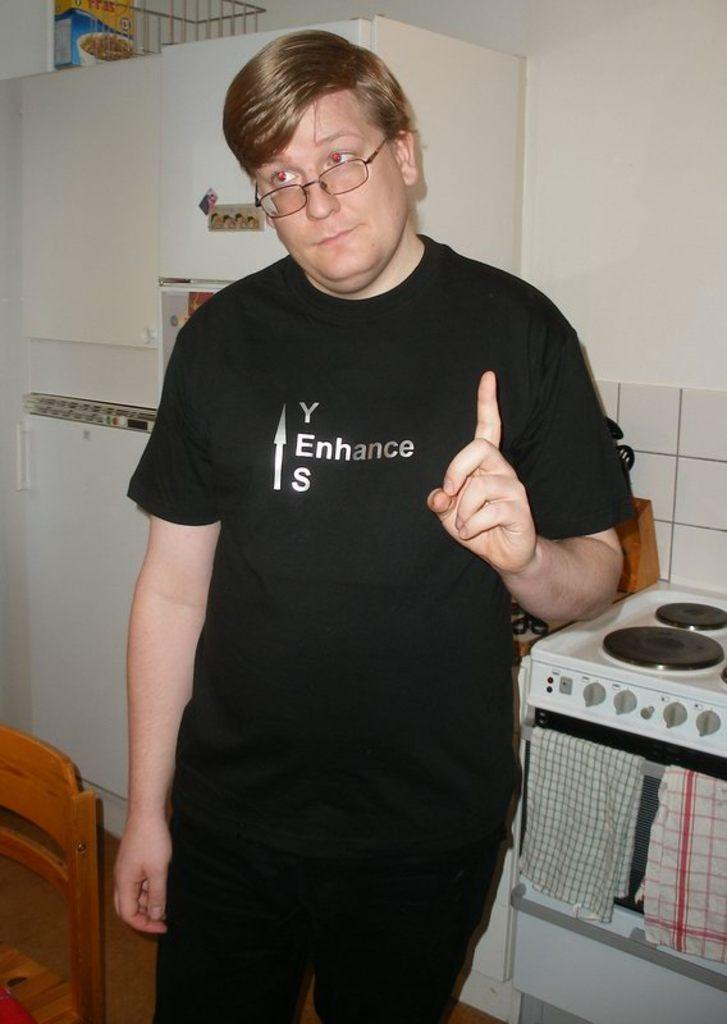<image>
Describe the image concisely. a man with glases and the word enhance on the shirt 